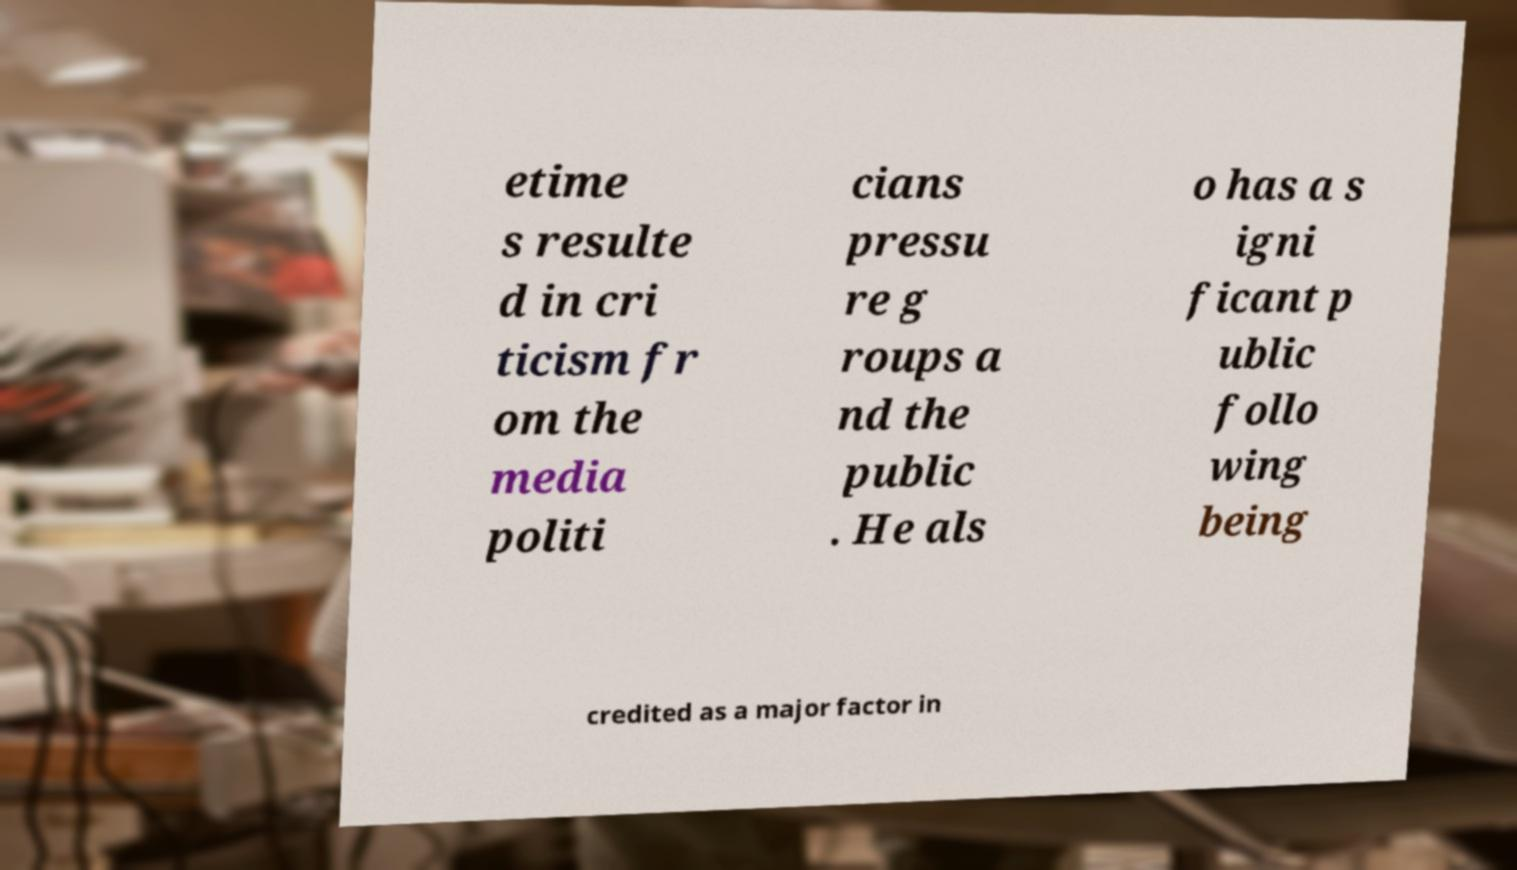Please identify and transcribe the text found in this image. etime s resulte d in cri ticism fr om the media politi cians pressu re g roups a nd the public . He als o has a s igni ficant p ublic follo wing being credited as a major factor in 